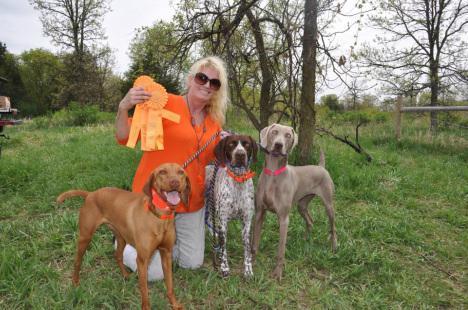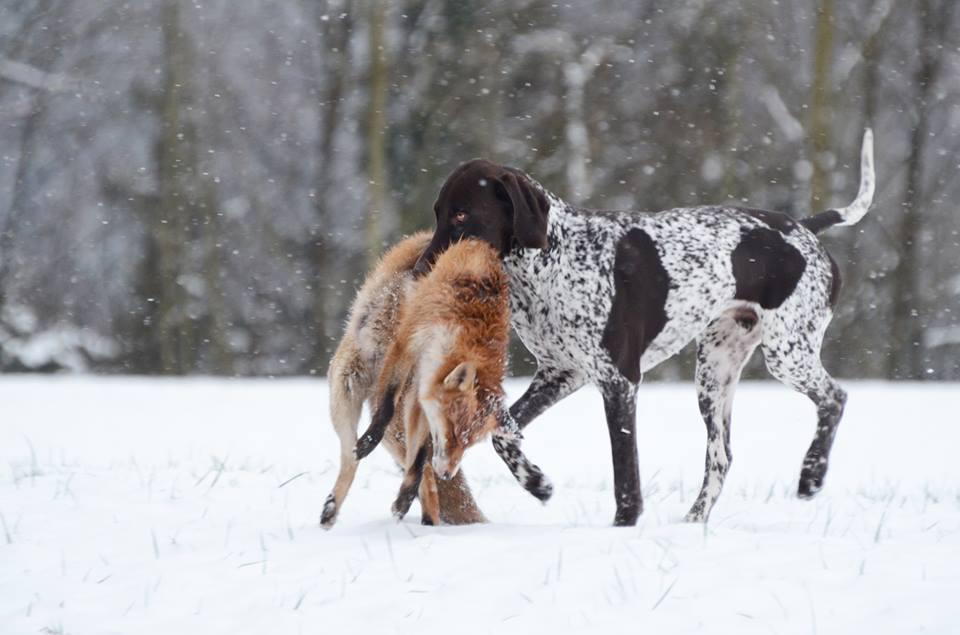The first image is the image on the left, the second image is the image on the right. For the images displayed, is the sentence "At least three dogs are sitting nicely in one of the pictures." factually correct? Answer yes or no. No. The first image is the image on the left, the second image is the image on the right. Examine the images to the left and right. Is the description "There are three dogs looking attentively forward." accurate? Answer yes or no. Yes. 